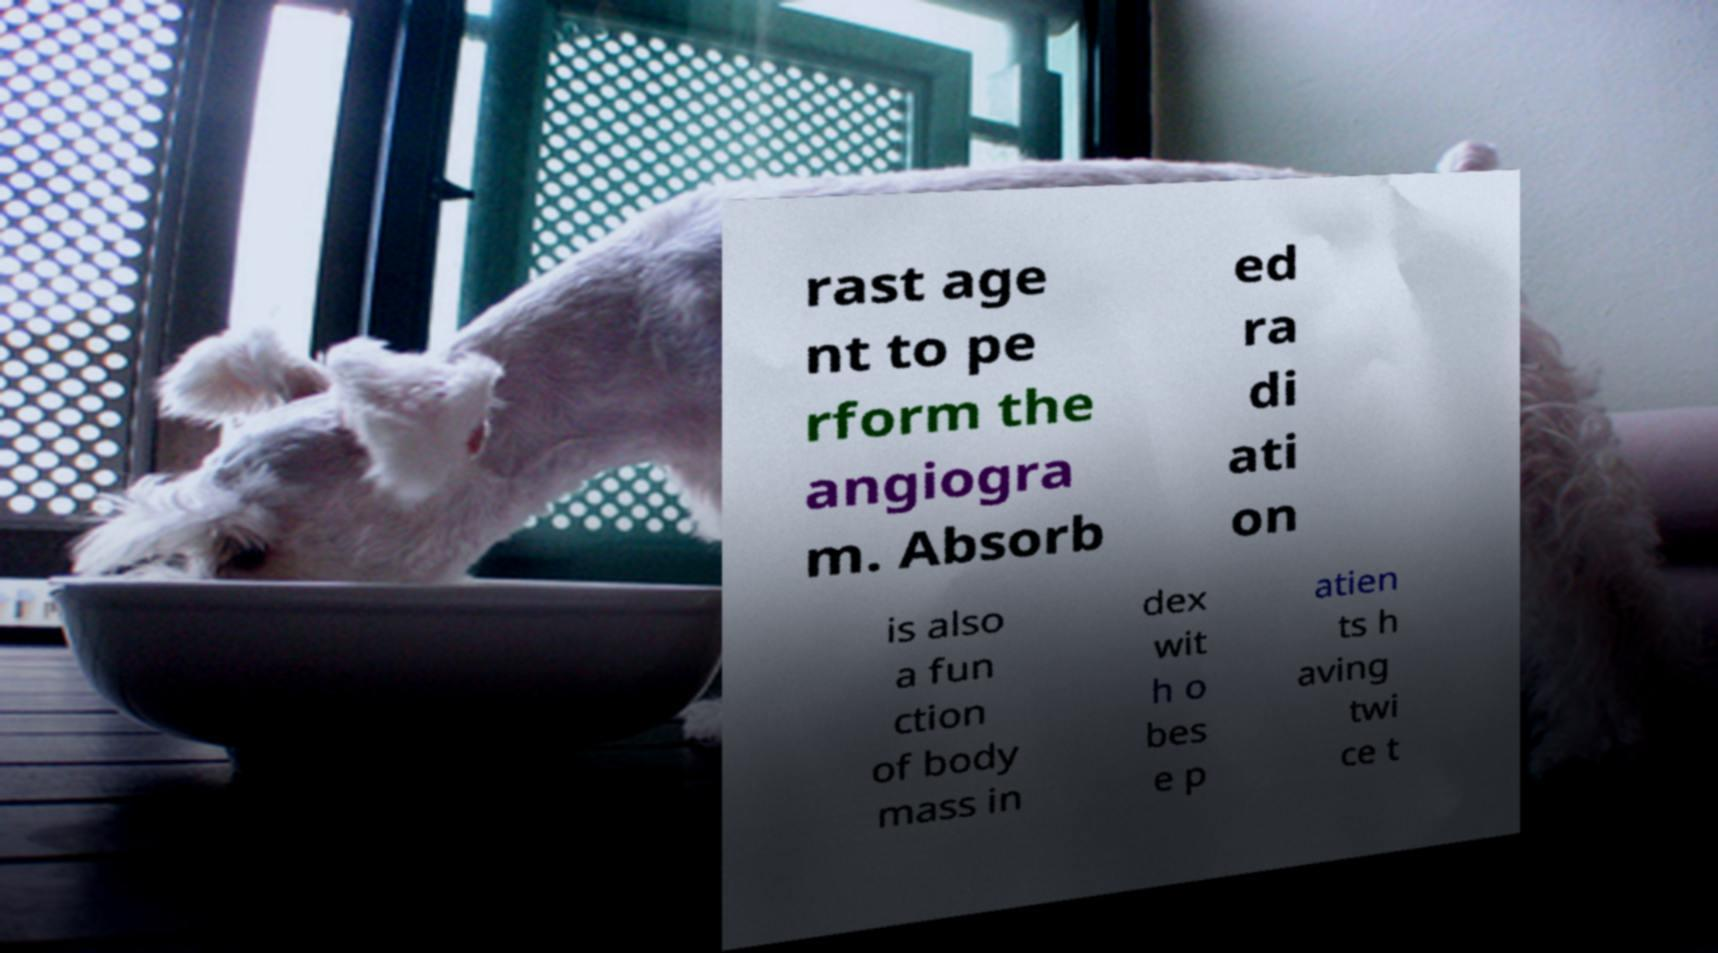There's text embedded in this image that I need extracted. Can you transcribe it verbatim? rast age nt to pe rform the angiogra m. Absorb ed ra di ati on is also a fun ction of body mass in dex wit h o bes e p atien ts h aving twi ce t 